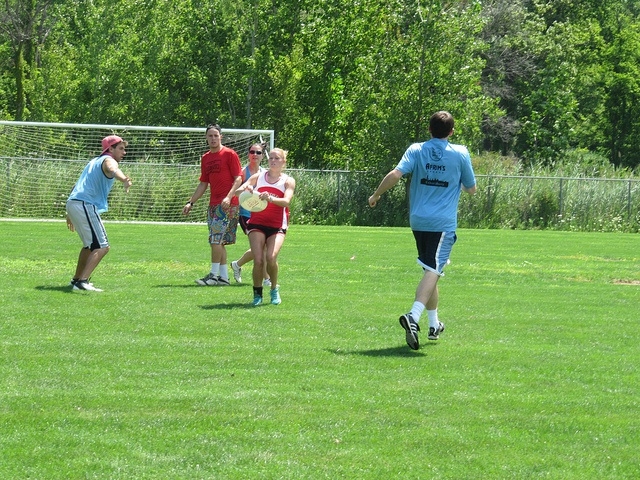Describe the objects in this image and their specific colors. I can see people in olive, teal, black, and gray tones, people in olive, gray, brown, and maroon tones, people in olive, white, brown, and gray tones, people in olive, gray, white, and lightblue tones, and people in olive, brown, darkgray, gray, and white tones in this image. 